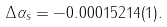<formula> <loc_0><loc_0><loc_500><loc_500>\Delta \alpha _ { s } = - 0 . 0 0 0 1 5 2 1 4 ( 1 ) .</formula> 